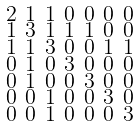<formula> <loc_0><loc_0><loc_500><loc_500>\begin{smallmatrix} 2 & 1 & 1 & 0 & 0 & 0 & 0 \\ 1 & 3 & 1 & 1 & 1 & 0 & 0 \\ 1 & 1 & 3 & 0 & 0 & 1 & 1 \\ 0 & 1 & 0 & 3 & 0 & 0 & 0 \\ 0 & 1 & 0 & 0 & 3 & 0 & 0 \\ 0 & 0 & 1 & 0 & 0 & 3 & 0 \\ 0 & 0 & 1 & 0 & 0 & 0 & 3 \end{smallmatrix}</formula> 